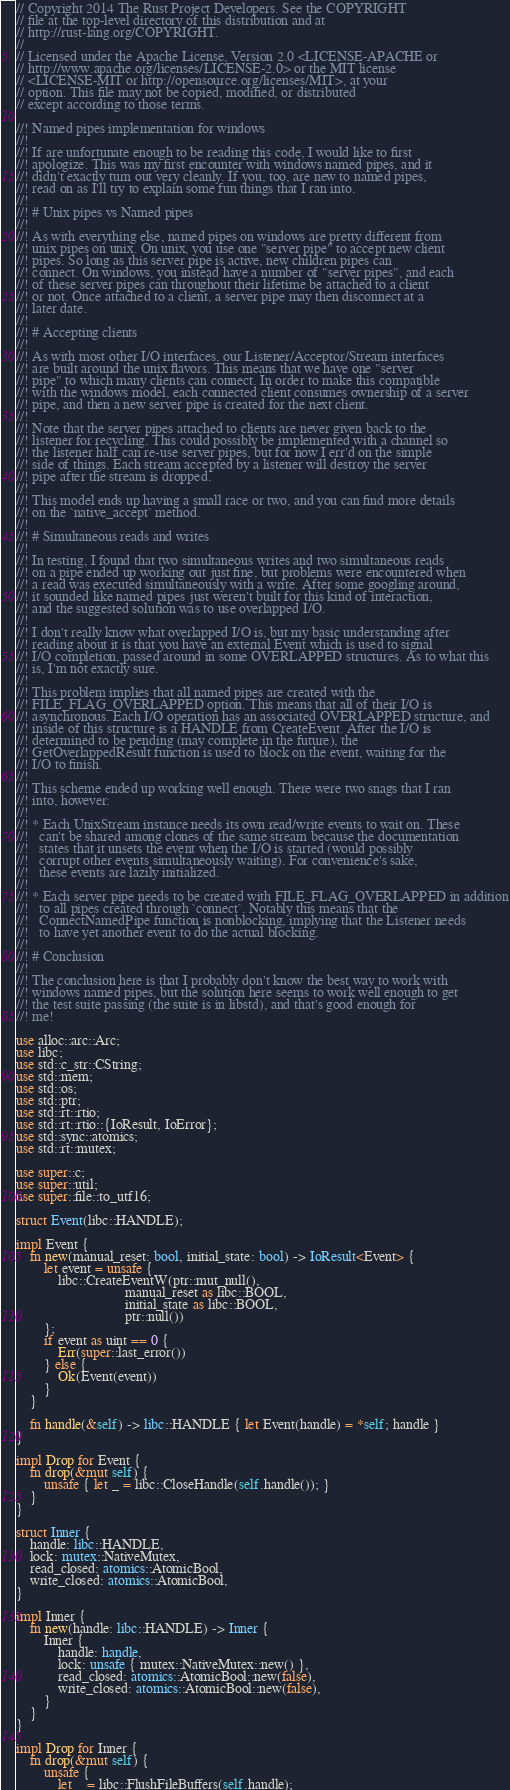Convert code to text. <code><loc_0><loc_0><loc_500><loc_500><_Rust_>// Copyright 2014 The Rust Project Developers. See the COPYRIGHT
// file at the top-level directory of this distribution and at
// http://rust-lang.org/COPYRIGHT.
//
// Licensed under the Apache License, Version 2.0 <LICENSE-APACHE or
// http://www.apache.org/licenses/LICENSE-2.0> or the MIT license
// <LICENSE-MIT or http://opensource.org/licenses/MIT>, at your
// option. This file may not be copied, modified, or distributed
// except according to those terms.

//! Named pipes implementation for windows
//!
//! If are unfortunate enough to be reading this code, I would like to first
//! apologize. This was my first encounter with windows named pipes, and it
//! didn't exactly turn out very cleanly. If you, too, are new to named pipes,
//! read on as I'll try to explain some fun things that I ran into.
//!
//! # Unix pipes vs Named pipes
//!
//! As with everything else, named pipes on windows are pretty different from
//! unix pipes on unix. On unix, you use one "server pipe" to accept new client
//! pipes. So long as this server pipe is active, new children pipes can
//! connect. On windows, you instead have a number of "server pipes", and each
//! of these server pipes can throughout their lifetime be attached to a client
//! or not. Once attached to a client, a server pipe may then disconnect at a
//! later date.
//!
//! # Accepting clients
//!
//! As with most other I/O interfaces, our Listener/Acceptor/Stream interfaces
//! are built around the unix flavors. This means that we have one "server
//! pipe" to which many clients can connect. In order to make this compatible
//! with the windows model, each connected client consumes ownership of a server
//! pipe, and then a new server pipe is created for the next client.
//!
//! Note that the server pipes attached to clients are never given back to the
//! listener for recycling. This could possibly be implemented with a channel so
//! the listener half can re-use server pipes, but for now I err'd on the simple
//! side of things. Each stream accepted by a listener will destroy the server
//! pipe after the stream is dropped.
//!
//! This model ends up having a small race or two, and you can find more details
//! on the `native_accept` method.
//!
//! # Simultaneous reads and writes
//!
//! In testing, I found that two simultaneous writes and two simultaneous reads
//! on a pipe ended up working out just fine, but problems were encountered when
//! a read was executed simultaneously with a write. After some googling around,
//! it sounded like named pipes just weren't built for this kind of interaction,
//! and the suggested solution was to use overlapped I/O.
//!
//! I don't really know what overlapped I/O is, but my basic understanding after
//! reading about it is that you have an external Event which is used to signal
//! I/O completion, passed around in some OVERLAPPED structures. As to what this
//! is, I'm not exactly sure.
//!
//! This problem implies that all named pipes are created with the
//! FILE_FLAG_OVERLAPPED option. This means that all of their I/O is
//! asynchronous. Each I/O operation has an associated OVERLAPPED structure, and
//! inside of this structure is a HANDLE from CreateEvent. After the I/O is
//! determined to be pending (may complete in the future), the
//! GetOverlappedResult function is used to block on the event, waiting for the
//! I/O to finish.
//!
//! This scheme ended up working well enough. There were two snags that I ran
//! into, however:
//!
//! * Each UnixStream instance needs its own read/write events to wait on. These
//!   can't be shared among clones of the same stream because the documentation
//!   states that it unsets the event when the I/O is started (would possibly
//!   corrupt other events simultaneously waiting). For convenience's sake,
//!   these events are lazily initialized.
//!
//! * Each server pipe needs to be created with FILE_FLAG_OVERLAPPED in addition
//!   to all pipes created through `connect`. Notably this means that the
//!   ConnectNamedPipe function is nonblocking, implying that the Listener needs
//!   to have yet another event to do the actual blocking.
//!
//! # Conclusion
//!
//! The conclusion here is that I probably don't know the best way to work with
//! windows named pipes, but the solution here seems to work well enough to get
//! the test suite passing (the suite is in libstd), and that's good enough for
//! me!

use alloc::arc::Arc;
use libc;
use std::c_str::CString;
use std::mem;
use std::os;
use std::ptr;
use std::rt::rtio;
use std::rt::rtio::{IoResult, IoError};
use std::sync::atomics;
use std::rt::mutex;

use super::c;
use super::util;
use super::file::to_utf16;

struct Event(libc::HANDLE);

impl Event {
    fn new(manual_reset: bool, initial_state: bool) -> IoResult<Event> {
        let event = unsafe {
            libc::CreateEventW(ptr::mut_null(),
                               manual_reset as libc::BOOL,
                               initial_state as libc::BOOL,
                               ptr::null())
        };
        if event as uint == 0 {
            Err(super::last_error())
        } else {
            Ok(Event(event))
        }
    }

    fn handle(&self) -> libc::HANDLE { let Event(handle) = *self; handle }
}

impl Drop for Event {
    fn drop(&mut self) {
        unsafe { let _ = libc::CloseHandle(self.handle()); }
    }
}

struct Inner {
    handle: libc::HANDLE,
    lock: mutex::NativeMutex,
    read_closed: atomics::AtomicBool,
    write_closed: atomics::AtomicBool,
}

impl Inner {
    fn new(handle: libc::HANDLE) -> Inner {
        Inner {
            handle: handle,
            lock: unsafe { mutex::NativeMutex::new() },
            read_closed: atomics::AtomicBool::new(false),
            write_closed: atomics::AtomicBool::new(false),
        }
    }
}

impl Drop for Inner {
    fn drop(&mut self) {
        unsafe {
            let _ = libc::FlushFileBuffers(self.handle);</code> 